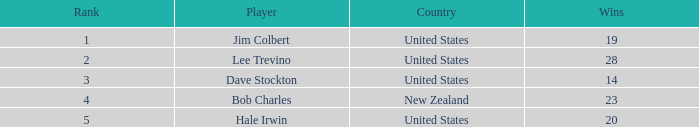How many players named bob charles with earnings over $7,646,958? 0.0. 